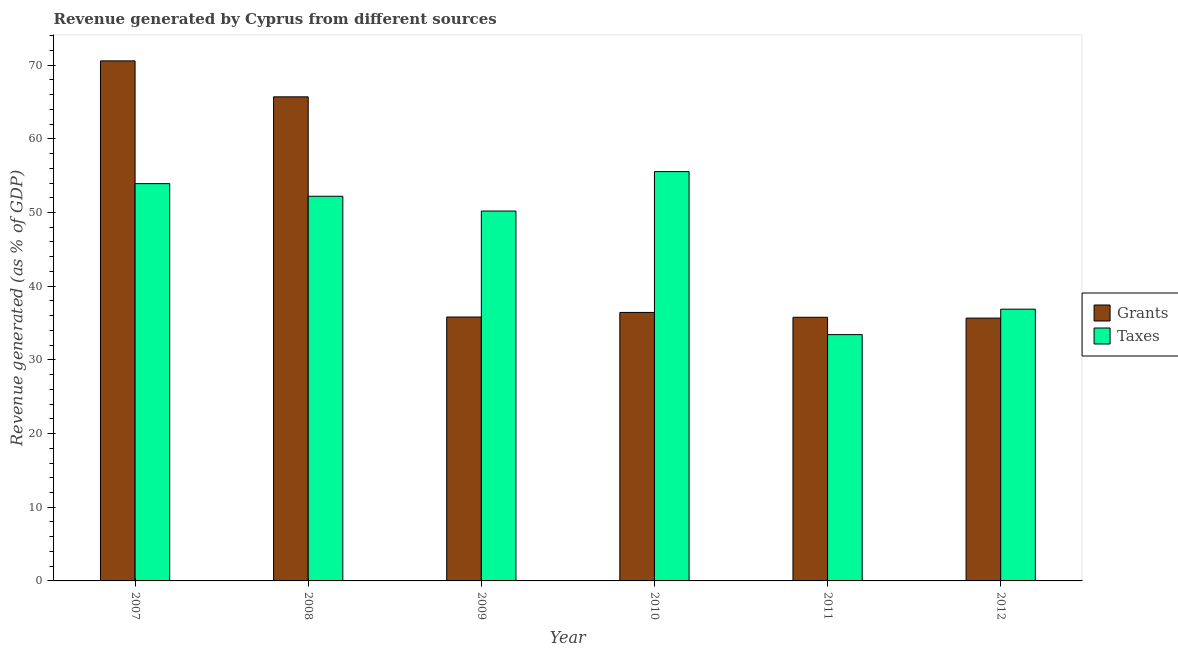How many different coloured bars are there?
Offer a very short reply. 2. How many groups of bars are there?
Give a very brief answer. 6. Are the number of bars per tick equal to the number of legend labels?
Make the answer very short. Yes. How many bars are there on the 3rd tick from the right?
Your answer should be very brief. 2. What is the label of the 5th group of bars from the left?
Offer a very short reply. 2011. In how many cases, is the number of bars for a given year not equal to the number of legend labels?
Ensure brevity in your answer.  0. What is the revenue generated by grants in 2008?
Provide a short and direct response. 65.7. Across all years, what is the maximum revenue generated by grants?
Provide a short and direct response. 70.58. Across all years, what is the minimum revenue generated by grants?
Provide a succinct answer. 35.67. What is the total revenue generated by taxes in the graph?
Give a very brief answer. 282.19. What is the difference between the revenue generated by taxes in 2010 and that in 2011?
Your answer should be compact. 22.13. What is the difference between the revenue generated by taxes in 2012 and the revenue generated by grants in 2008?
Your answer should be very brief. -15.32. What is the average revenue generated by taxes per year?
Make the answer very short. 47.03. In how many years, is the revenue generated by grants greater than 38 %?
Provide a short and direct response. 2. What is the ratio of the revenue generated by grants in 2007 to that in 2008?
Ensure brevity in your answer.  1.07. Is the revenue generated by taxes in 2011 less than that in 2012?
Offer a terse response. Yes. Is the difference between the revenue generated by grants in 2010 and 2011 greater than the difference between the revenue generated by taxes in 2010 and 2011?
Provide a short and direct response. No. What is the difference between the highest and the second highest revenue generated by grants?
Your answer should be very brief. 4.88. What is the difference between the highest and the lowest revenue generated by taxes?
Offer a very short reply. 22.13. What does the 1st bar from the left in 2007 represents?
Your answer should be compact. Grants. What does the 1st bar from the right in 2007 represents?
Your answer should be very brief. Taxes. How many bars are there?
Ensure brevity in your answer.  12. Are all the bars in the graph horizontal?
Offer a very short reply. No. Are the values on the major ticks of Y-axis written in scientific E-notation?
Provide a succinct answer. No. Does the graph contain any zero values?
Offer a terse response. No. Where does the legend appear in the graph?
Provide a short and direct response. Center right. How many legend labels are there?
Provide a succinct answer. 2. How are the legend labels stacked?
Offer a very short reply. Vertical. What is the title of the graph?
Provide a succinct answer. Revenue generated by Cyprus from different sources. What is the label or title of the X-axis?
Ensure brevity in your answer.  Year. What is the label or title of the Y-axis?
Your answer should be very brief. Revenue generated (as % of GDP). What is the Revenue generated (as % of GDP) in Grants in 2007?
Keep it short and to the point. 70.58. What is the Revenue generated (as % of GDP) in Taxes in 2007?
Make the answer very short. 53.92. What is the Revenue generated (as % of GDP) of Grants in 2008?
Your answer should be very brief. 65.7. What is the Revenue generated (as % of GDP) of Taxes in 2008?
Make the answer very short. 52.21. What is the Revenue generated (as % of GDP) of Grants in 2009?
Provide a short and direct response. 35.82. What is the Revenue generated (as % of GDP) of Taxes in 2009?
Offer a very short reply. 50.2. What is the Revenue generated (as % of GDP) of Grants in 2010?
Make the answer very short. 36.44. What is the Revenue generated (as % of GDP) in Taxes in 2010?
Make the answer very short. 55.56. What is the Revenue generated (as % of GDP) in Grants in 2011?
Keep it short and to the point. 35.78. What is the Revenue generated (as % of GDP) of Taxes in 2011?
Provide a short and direct response. 33.43. What is the Revenue generated (as % of GDP) in Grants in 2012?
Provide a succinct answer. 35.67. What is the Revenue generated (as % of GDP) of Taxes in 2012?
Make the answer very short. 36.88. Across all years, what is the maximum Revenue generated (as % of GDP) of Grants?
Make the answer very short. 70.58. Across all years, what is the maximum Revenue generated (as % of GDP) in Taxes?
Provide a short and direct response. 55.56. Across all years, what is the minimum Revenue generated (as % of GDP) in Grants?
Give a very brief answer. 35.67. Across all years, what is the minimum Revenue generated (as % of GDP) of Taxes?
Make the answer very short. 33.43. What is the total Revenue generated (as % of GDP) of Grants in the graph?
Offer a very short reply. 279.99. What is the total Revenue generated (as % of GDP) in Taxes in the graph?
Your response must be concise. 282.19. What is the difference between the Revenue generated (as % of GDP) of Grants in 2007 and that in 2008?
Make the answer very short. 4.88. What is the difference between the Revenue generated (as % of GDP) of Taxes in 2007 and that in 2008?
Ensure brevity in your answer.  1.71. What is the difference between the Revenue generated (as % of GDP) in Grants in 2007 and that in 2009?
Give a very brief answer. 34.77. What is the difference between the Revenue generated (as % of GDP) in Taxes in 2007 and that in 2009?
Your answer should be compact. 3.72. What is the difference between the Revenue generated (as % of GDP) in Grants in 2007 and that in 2010?
Provide a succinct answer. 34.14. What is the difference between the Revenue generated (as % of GDP) in Taxes in 2007 and that in 2010?
Provide a succinct answer. -1.63. What is the difference between the Revenue generated (as % of GDP) in Grants in 2007 and that in 2011?
Provide a short and direct response. 34.8. What is the difference between the Revenue generated (as % of GDP) in Taxes in 2007 and that in 2011?
Ensure brevity in your answer.  20.49. What is the difference between the Revenue generated (as % of GDP) in Grants in 2007 and that in 2012?
Give a very brief answer. 34.91. What is the difference between the Revenue generated (as % of GDP) in Taxes in 2007 and that in 2012?
Your response must be concise. 17.04. What is the difference between the Revenue generated (as % of GDP) in Grants in 2008 and that in 2009?
Provide a succinct answer. 29.88. What is the difference between the Revenue generated (as % of GDP) in Taxes in 2008 and that in 2009?
Provide a succinct answer. 2.01. What is the difference between the Revenue generated (as % of GDP) of Grants in 2008 and that in 2010?
Offer a terse response. 29.26. What is the difference between the Revenue generated (as % of GDP) of Taxes in 2008 and that in 2010?
Your answer should be very brief. -3.35. What is the difference between the Revenue generated (as % of GDP) of Grants in 2008 and that in 2011?
Give a very brief answer. 29.92. What is the difference between the Revenue generated (as % of GDP) of Taxes in 2008 and that in 2011?
Your answer should be very brief. 18.78. What is the difference between the Revenue generated (as % of GDP) in Grants in 2008 and that in 2012?
Your answer should be very brief. 30.03. What is the difference between the Revenue generated (as % of GDP) of Taxes in 2008 and that in 2012?
Your answer should be compact. 15.32. What is the difference between the Revenue generated (as % of GDP) in Grants in 2009 and that in 2010?
Ensure brevity in your answer.  -0.62. What is the difference between the Revenue generated (as % of GDP) of Taxes in 2009 and that in 2010?
Provide a succinct answer. -5.35. What is the difference between the Revenue generated (as % of GDP) of Grants in 2009 and that in 2011?
Make the answer very short. 0.03. What is the difference between the Revenue generated (as % of GDP) of Taxes in 2009 and that in 2011?
Give a very brief answer. 16.78. What is the difference between the Revenue generated (as % of GDP) of Grants in 2009 and that in 2012?
Provide a succinct answer. 0.14. What is the difference between the Revenue generated (as % of GDP) of Taxes in 2009 and that in 2012?
Offer a very short reply. 13.32. What is the difference between the Revenue generated (as % of GDP) in Grants in 2010 and that in 2011?
Provide a succinct answer. 0.66. What is the difference between the Revenue generated (as % of GDP) in Taxes in 2010 and that in 2011?
Offer a very short reply. 22.13. What is the difference between the Revenue generated (as % of GDP) in Grants in 2010 and that in 2012?
Offer a very short reply. 0.77. What is the difference between the Revenue generated (as % of GDP) of Taxes in 2010 and that in 2012?
Your answer should be compact. 18.67. What is the difference between the Revenue generated (as % of GDP) of Grants in 2011 and that in 2012?
Provide a succinct answer. 0.11. What is the difference between the Revenue generated (as % of GDP) in Taxes in 2011 and that in 2012?
Provide a short and direct response. -3.46. What is the difference between the Revenue generated (as % of GDP) in Grants in 2007 and the Revenue generated (as % of GDP) in Taxes in 2008?
Make the answer very short. 18.37. What is the difference between the Revenue generated (as % of GDP) of Grants in 2007 and the Revenue generated (as % of GDP) of Taxes in 2009?
Provide a succinct answer. 20.38. What is the difference between the Revenue generated (as % of GDP) in Grants in 2007 and the Revenue generated (as % of GDP) in Taxes in 2010?
Provide a succinct answer. 15.03. What is the difference between the Revenue generated (as % of GDP) in Grants in 2007 and the Revenue generated (as % of GDP) in Taxes in 2011?
Provide a short and direct response. 37.16. What is the difference between the Revenue generated (as % of GDP) of Grants in 2007 and the Revenue generated (as % of GDP) of Taxes in 2012?
Offer a very short reply. 33.7. What is the difference between the Revenue generated (as % of GDP) of Grants in 2008 and the Revenue generated (as % of GDP) of Taxes in 2009?
Keep it short and to the point. 15.5. What is the difference between the Revenue generated (as % of GDP) of Grants in 2008 and the Revenue generated (as % of GDP) of Taxes in 2010?
Keep it short and to the point. 10.15. What is the difference between the Revenue generated (as % of GDP) in Grants in 2008 and the Revenue generated (as % of GDP) in Taxes in 2011?
Your response must be concise. 32.27. What is the difference between the Revenue generated (as % of GDP) of Grants in 2008 and the Revenue generated (as % of GDP) of Taxes in 2012?
Keep it short and to the point. 28.82. What is the difference between the Revenue generated (as % of GDP) of Grants in 2009 and the Revenue generated (as % of GDP) of Taxes in 2010?
Offer a very short reply. -19.74. What is the difference between the Revenue generated (as % of GDP) of Grants in 2009 and the Revenue generated (as % of GDP) of Taxes in 2011?
Your response must be concise. 2.39. What is the difference between the Revenue generated (as % of GDP) of Grants in 2009 and the Revenue generated (as % of GDP) of Taxes in 2012?
Provide a short and direct response. -1.07. What is the difference between the Revenue generated (as % of GDP) of Grants in 2010 and the Revenue generated (as % of GDP) of Taxes in 2011?
Provide a short and direct response. 3.01. What is the difference between the Revenue generated (as % of GDP) in Grants in 2010 and the Revenue generated (as % of GDP) in Taxes in 2012?
Offer a terse response. -0.44. What is the difference between the Revenue generated (as % of GDP) in Grants in 2011 and the Revenue generated (as % of GDP) in Taxes in 2012?
Offer a very short reply. -1.1. What is the average Revenue generated (as % of GDP) in Grants per year?
Provide a short and direct response. 46.67. What is the average Revenue generated (as % of GDP) in Taxes per year?
Your answer should be very brief. 47.03. In the year 2007, what is the difference between the Revenue generated (as % of GDP) in Grants and Revenue generated (as % of GDP) in Taxes?
Make the answer very short. 16.66. In the year 2008, what is the difference between the Revenue generated (as % of GDP) of Grants and Revenue generated (as % of GDP) of Taxes?
Your answer should be very brief. 13.49. In the year 2009, what is the difference between the Revenue generated (as % of GDP) of Grants and Revenue generated (as % of GDP) of Taxes?
Keep it short and to the point. -14.39. In the year 2010, what is the difference between the Revenue generated (as % of GDP) in Grants and Revenue generated (as % of GDP) in Taxes?
Ensure brevity in your answer.  -19.12. In the year 2011, what is the difference between the Revenue generated (as % of GDP) in Grants and Revenue generated (as % of GDP) in Taxes?
Ensure brevity in your answer.  2.36. In the year 2012, what is the difference between the Revenue generated (as % of GDP) of Grants and Revenue generated (as % of GDP) of Taxes?
Provide a short and direct response. -1.21. What is the ratio of the Revenue generated (as % of GDP) of Grants in 2007 to that in 2008?
Offer a very short reply. 1.07. What is the ratio of the Revenue generated (as % of GDP) in Taxes in 2007 to that in 2008?
Your answer should be very brief. 1.03. What is the ratio of the Revenue generated (as % of GDP) of Grants in 2007 to that in 2009?
Your answer should be very brief. 1.97. What is the ratio of the Revenue generated (as % of GDP) in Taxes in 2007 to that in 2009?
Give a very brief answer. 1.07. What is the ratio of the Revenue generated (as % of GDP) of Grants in 2007 to that in 2010?
Give a very brief answer. 1.94. What is the ratio of the Revenue generated (as % of GDP) in Taxes in 2007 to that in 2010?
Provide a short and direct response. 0.97. What is the ratio of the Revenue generated (as % of GDP) of Grants in 2007 to that in 2011?
Keep it short and to the point. 1.97. What is the ratio of the Revenue generated (as % of GDP) of Taxes in 2007 to that in 2011?
Your response must be concise. 1.61. What is the ratio of the Revenue generated (as % of GDP) of Grants in 2007 to that in 2012?
Your answer should be very brief. 1.98. What is the ratio of the Revenue generated (as % of GDP) of Taxes in 2007 to that in 2012?
Your answer should be very brief. 1.46. What is the ratio of the Revenue generated (as % of GDP) in Grants in 2008 to that in 2009?
Provide a short and direct response. 1.83. What is the ratio of the Revenue generated (as % of GDP) in Grants in 2008 to that in 2010?
Make the answer very short. 1.8. What is the ratio of the Revenue generated (as % of GDP) in Taxes in 2008 to that in 2010?
Offer a very short reply. 0.94. What is the ratio of the Revenue generated (as % of GDP) in Grants in 2008 to that in 2011?
Provide a succinct answer. 1.84. What is the ratio of the Revenue generated (as % of GDP) of Taxes in 2008 to that in 2011?
Offer a very short reply. 1.56. What is the ratio of the Revenue generated (as % of GDP) of Grants in 2008 to that in 2012?
Provide a short and direct response. 1.84. What is the ratio of the Revenue generated (as % of GDP) of Taxes in 2008 to that in 2012?
Ensure brevity in your answer.  1.42. What is the ratio of the Revenue generated (as % of GDP) in Grants in 2009 to that in 2010?
Provide a short and direct response. 0.98. What is the ratio of the Revenue generated (as % of GDP) in Taxes in 2009 to that in 2010?
Give a very brief answer. 0.9. What is the ratio of the Revenue generated (as % of GDP) in Taxes in 2009 to that in 2011?
Offer a terse response. 1.5. What is the ratio of the Revenue generated (as % of GDP) of Taxes in 2009 to that in 2012?
Make the answer very short. 1.36. What is the ratio of the Revenue generated (as % of GDP) in Grants in 2010 to that in 2011?
Ensure brevity in your answer.  1.02. What is the ratio of the Revenue generated (as % of GDP) in Taxes in 2010 to that in 2011?
Provide a succinct answer. 1.66. What is the ratio of the Revenue generated (as % of GDP) in Grants in 2010 to that in 2012?
Provide a succinct answer. 1.02. What is the ratio of the Revenue generated (as % of GDP) in Taxes in 2010 to that in 2012?
Provide a short and direct response. 1.51. What is the ratio of the Revenue generated (as % of GDP) of Taxes in 2011 to that in 2012?
Give a very brief answer. 0.91. What is the difference between the highest and the second highest Revenue generated (as % of GDP) in Grants?
Keep it short and to the point. 4.88. What is the difference between the highest and the second highest Revenue generated (as % of GDP) of Taxes?
Your answer should be compact. 1.63. What is the difference between the highest and the lowest Revenue generated (as % of GDP) of Grants?
Your response must be concise. 34.91. What is the difference between the highest and the lowest Revenue generated (as % of GDP) in Taxes?
Ensure brevity in your answer.  22.13. 